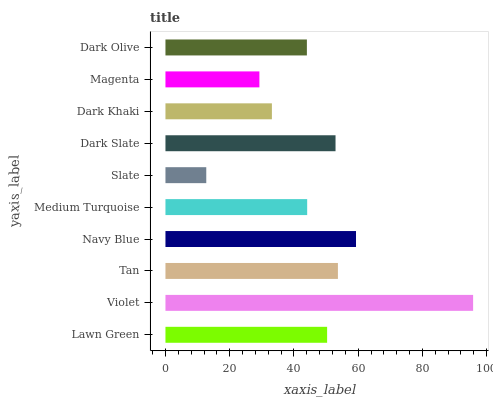Is Slate the minimum?
Answer yes or no. Yes. Is Violet the maximum?
Answer yes or no. Yes. Is Tan the minimum?
Answer yes or no. No. Is Tan the maximum?
Answer yes or no. No. Is Violet greater than Tan?
Answer yes or no. Yes. Is Tan less than Violet?
Answer yes or no. Yes. Is Tan greater than Violet?
Answer yes or no. No. Is Violet less than Tan?
Answer yes or no. No. Is Lawn Green the high median?
Answer yes or no. Yes. Is Medium Turquoise the low median?
Answer yes or no. Yes. Is Violet the high median?
Answer yes or no. No. Is Magenta the low median?
Answer yes or no. No. 